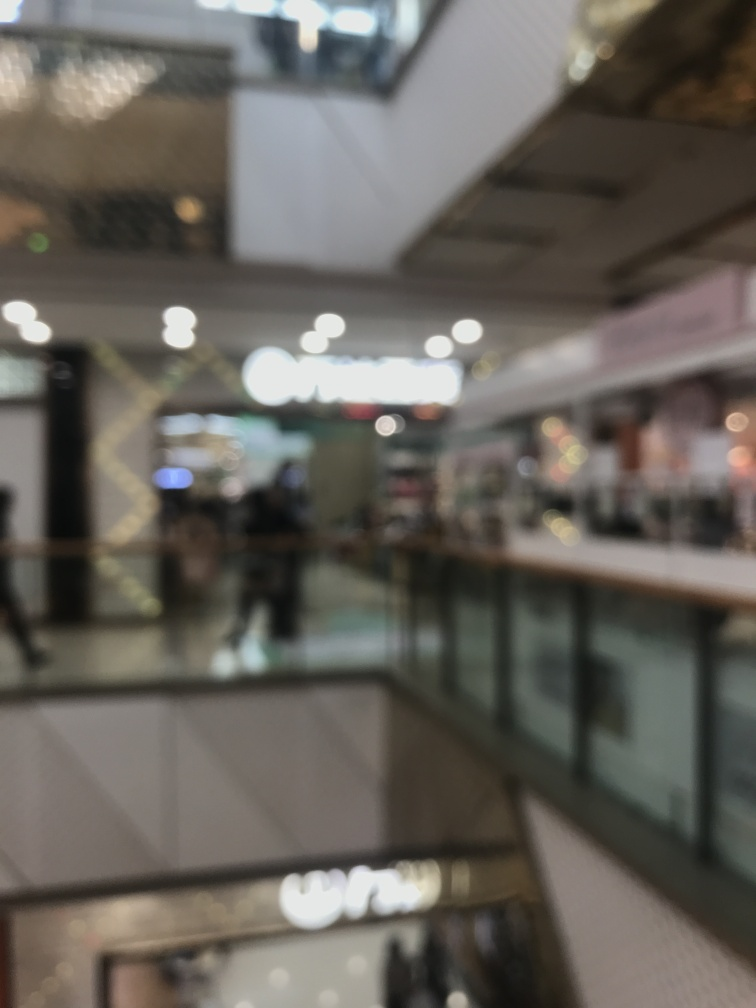Can you describe the type of location shown in this blurry image? While the specific details are unclear due to the image's low clarity, it appears to be an indoor setting with artificial lighting, possibly a shopping mall or retail area, as suggested by the presence of what seem to be shopfronts and a railing indicating multiple levels. 